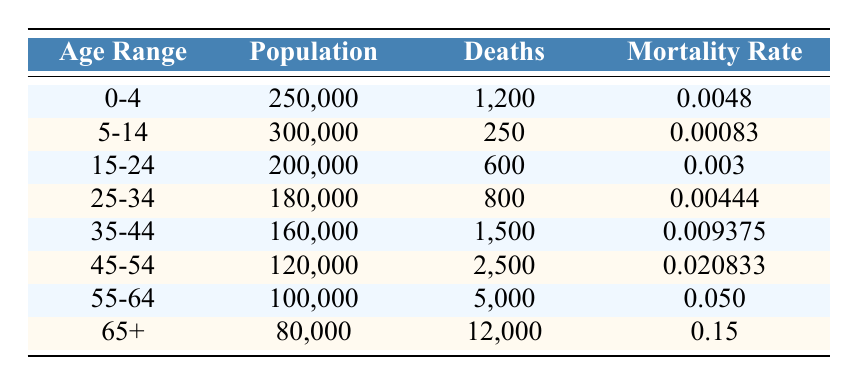What is the mortality rate for the age group 55-64? The table lists the mortality rate for the age group 55-64 as 0.050.
Answer: 0.050 How many deaths occurred in the 45-54 age group? The table indicates that there were 2,500 deaths in the 45-54 age group.
Answer: 2,500 What is the total population of all age groups combined? To find the total population, add the populations of each age group: 250,000 + 300,000 + 200,000 + 180,000 + 160,000 + 120,000 + 100,000 + 80,000 = 1,390,000.
Answer: 1,390,000 Is the mortality rate for the age group 35-44 higher than that for the age group 15-24? Comparing the mortality rates, the rate for 35-44 is 0.009375, while for 15-24 it is 0.003, which means 0.009375 is higher.
Answer: Yes What percentage of deaths occurred in the age group 65+ compared to the total deaths across all age groups? First, sum the total deaths: 1200 + 250 + 600 + 800 + 1500 + 2500 + 5000 + 12000 = 20,850. Then, find the percentage of deaths in the 65+ age group: (12000 / 20850) * 100 = 57.6%.
Answer: 57.6% What is the age group with the lowest mortality rate? The age group 5-14 has the lowest mortality rate of 0.00083 according to the table.
Answer: 5-14 What would be the average mortality rate for all age groups? To find the average, calculate the sum of all mortality rates: 0.0048 + 0.00083 + 0.003 + 0.00444 + 0.009375 + 0.020833 + 0.050 + 0.15 = 0.243771. Then divide by 8 (the number of age groups) to get the average: 0.243771 / 8 = 0.030471375, which rounds to 0.0305.
Answer: 0.0305 Is the population of the 55-64 age group higher than that of the 45-54 age group? The table shows that the 55-64 age group has a population of 100,000 while the 45-54 age group has a population of 120,000, so the latter is higher.
Answer: No 